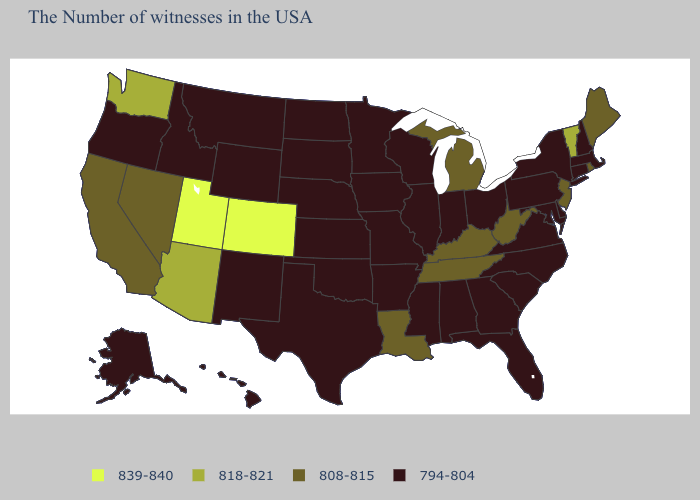What is the value of Vermont?
Write a very short answer. 818-821. Name the states that have a value in the range 818-821?
Short answer required. Vermont, Arizona, Washington. Among the states that border Delaware , which have the highest value?
Answer briefly. New Jersey. Does the first symbol in the legend represent the smallest category?
Answer briefly. No. Is the legend a continuous bar?
Concise answer only. No. Name the states that have a value in the range 794-804?
Quick response, please. Massachusetts, New Hampshire, Connecticut, New York, Delaware, Maryland, Pennsylvania, Virginia, North Carolina, South Carolina, Ohio, Florida, Georgia, Indiana, Alabama, Wisconsin, Illinois, Mississippi, Missouri, Arkansas, Minnesota, Iowa, Kansas, Nebraska, Oklahoma, Texas, South Dakota, North Dakota, Wyoming, New Mexico, Montana, Idaho, Oregon, Alaska, Hawaii. What is the highest value in the MidWest ?
Give a very brief answer. 808-815. What is the highest value in the West ?
Concise answer only. 839-840. What is the highest value in the MidWest ?
Concise answer only. 808-815. Does Florida have the lowest value in the South?
Be succinct. Yes. Among the states that border Vermont , which have the lowest value?
Answer briefly. Massachusetts, New Hampshire, New York. Name the states that have a value in the range 808-815?
Short answer required. Maine, Rhode Island, New Jersey, West Virginia, Michigan, Kentucky, Tennessee, Louisiana, Nevada, California. Name the states that have a value in the range 839-840?
Be succinct. Colorado, Utah. Among the states that border Oklahoma , does Kansas have the highest value?
Quick response, please. No. 